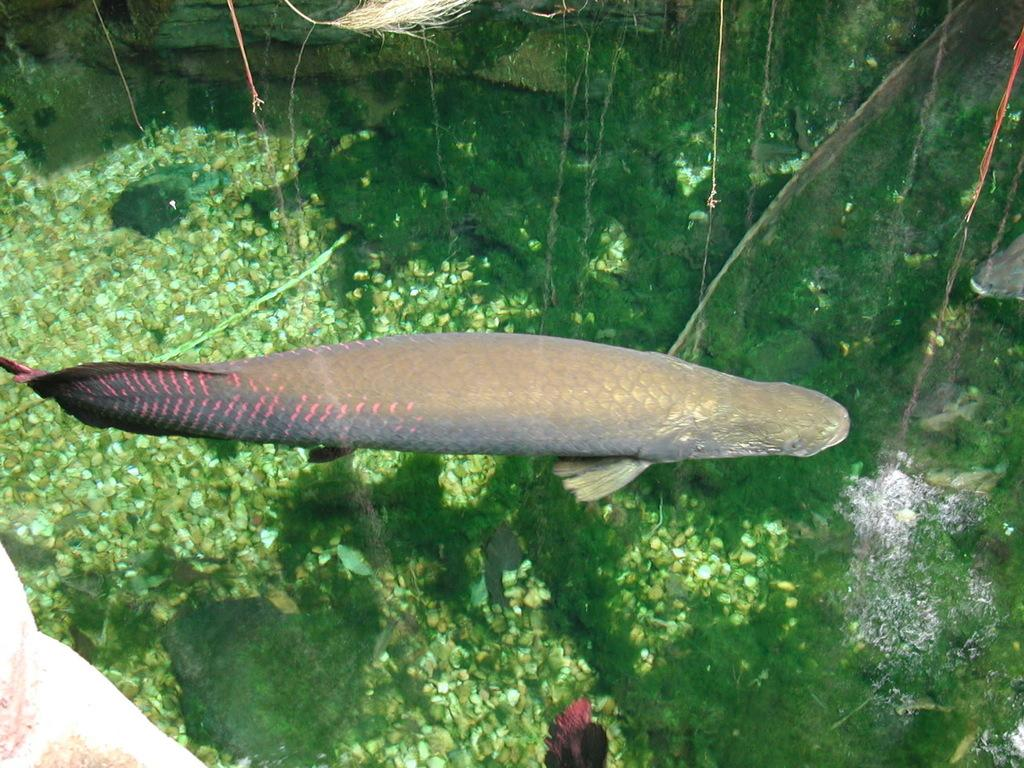What type of living organisms can be seen in the image? Plants and fish are visible in the image. Where are the fish located in the image? The fish are underwater in the image. Can you describe the environment in which the fish are located? The fish are in an underwater environment, likely an aquarium or a natural body of water. What is the chin of the fish in the image? Fish do not have chins, as they are aquatic animals without a chin structure. 